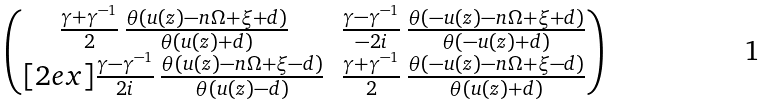<formula> <loc_0><loc_0><loc_500><loc_500>\begin{pmatrix} \frac { \gamma + \gamma ^ { - 1 } } { 2 } \, \frac { \theta ( u ( z ) - n \Omega + \xi + d ) } { \theta ( u ( z ) + d ) } & \frac { \gamma - \gamma ^ { - 1 } } { - 2 i } \, \frac { \theta ( - u ( z ) - n \Omega + \xi + d ) } { \theta ( - u ( z ) + d ) } \\ [ 2 e x ] \frac { \gamma - \gamma ^ { - 1 } } { 2 i } \, \frac { \theta ( u ( z ) - n \Omega + \xi - d ) } { \theta ( u ( z ) - d ) } & \frac { \gamma + \gamma ^ { - 1 } } { 2 } \, \frac { \theta ( - u ( z ) - n \Omega + \xi - d ) } { \theta ( u ( z ) + d ) } \end{pmatrix}</formula> 